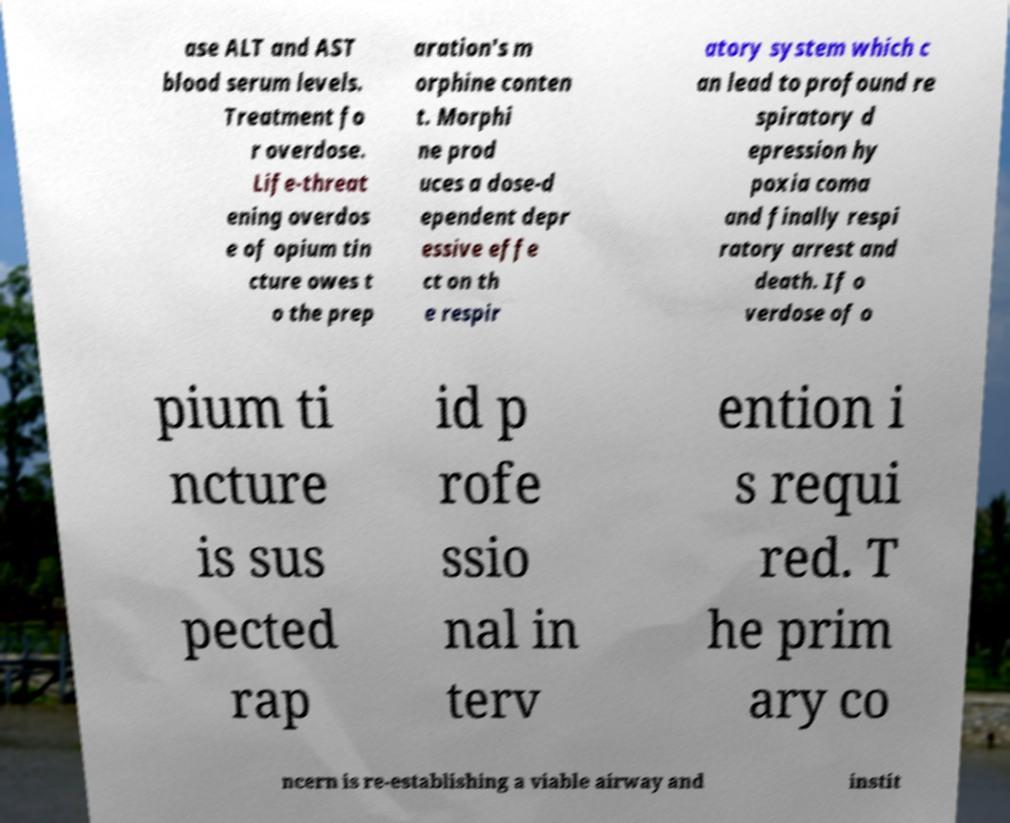There's text embedded in this image that I need extracted. Can you transcribe it verbatim? ase ALT and AST blood serum levels. Treatment fo r overdose. Life-threat ening overdos e of opium tin cture owes t o the prep aration's m orphine conten t. Morphi ne prod uces a dose-d ependent depr essive effe ct on th e respir atory system which c an lead to profound re spiratory d epression hy poxia coma and finally respi ratory arrest and death. If o verdose of o pium ti ncture is sus pected rap id p rofe ssio nal in terv ention i s requi red. T he prim ary co ncern is re-establishing a viable airway and instit 